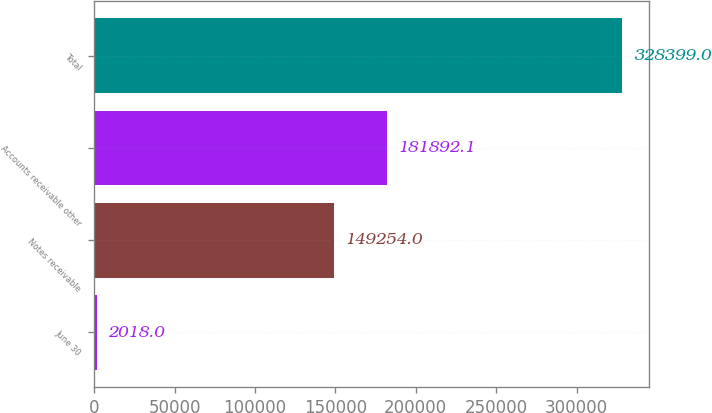Convert chart to OTSL. <chart><loc_0><loc_0><loc_500><loc_500><bar_chart><fcel>June 30<fcel>Notes receivable<fcel>Accounts receivable other<fcel>Total<nl><fcel>2018<fcel>149254<fcel>181892<fcel>328399<nl></chart> 